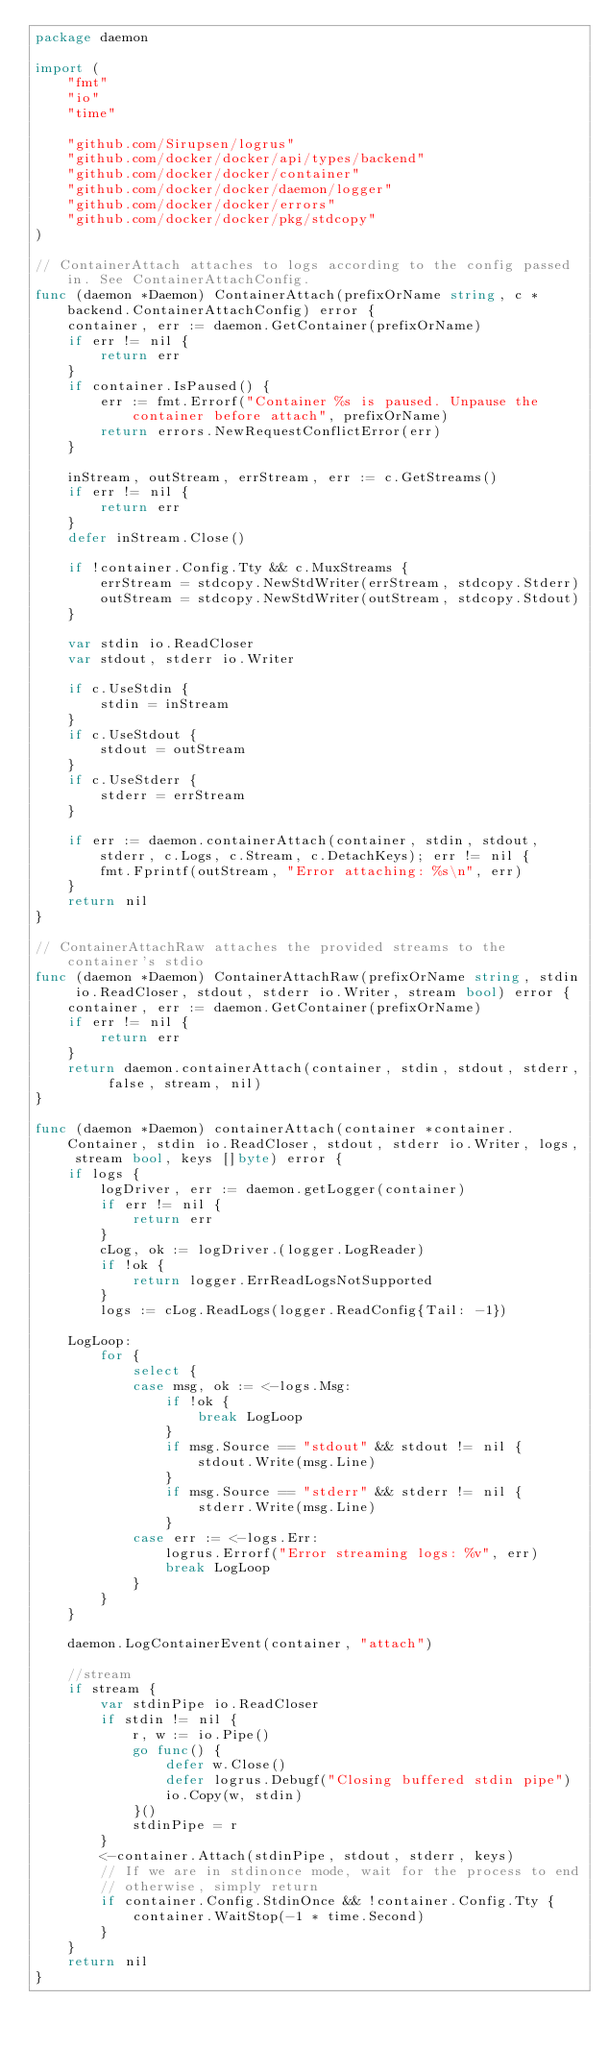<code> <loc_0><loc_0><loc_500><loc_500><_Go_>package daemon

import (
	"fmt"
	"io"
	"time"

	"github.com/Sirupsen/logrus"
	"github.com/docker/docker/api/types/backend"
	"github.com/docker/docker/container"
	"github.com/docker/docker/daemon/logger"
	"github.com/docker/docker/errors"
	"github.com/docker/docker/pkg/stdcopy"
)

// ContainerAttach attaches to logs according to the config passed in. See ContainerAttachConfig.
func (daemon *Daemon) ContainerAttach(prefixOrName string, c *backend.ContainerAttachConfig) error {
	container, err := daemon.GetContainer(prefixOrName)
	if err != nil {
		return err
	}
	if container.IsPaused() {
		err := fmt.Errorf("Container %s is paused. Unpause the container before attach", prefixOrName)
		return errors.NewRequestConflictError(err)
	}

	inStream, outStream, errStream, err := c.GetStreams()
	if err != nil {
		return err
	}
	defer inStream.Close()

	if !container.Config.Tty && c.MuxStreams {
		errStream = stdcopy.NewStdWriter(errStream, stdcopy.Stderr)
		outStream = stdcopy.NewStdWriter(outStream, stdcopy.Stdout)
	}

	var stdin io.ReadCloser
	var stdout, stderr io.Writer

	if c.UseStdin {
		stdin = inStream
	}
	if c.UseStdout {
		stdout = outStream
	}
	if c.UseStderr {
		stderr = errStream
	}

	if err := daemon.containerAttach(container, stdin, stdout, stderr, c.Logs, c.Stream, c.DetachKeys); err != nil {
		fmt.Fprintf(outStream, "Error attaching: %s\n", err)
	}
	return nil
}

// ContainerAttachRaw attaches the provided streams to the container's stdio
func (daemon *Daemon) ContainerAttachRaw(prefixOrName string, stdin io.ReadCloser, stdout, stderr io.Writer, stream bool) error {
	container, err := daemon.GetContainer(prefixOrName)
	if err != nil {
		return err
	}
	return daemon.containerAttach(container, stdin, stdout, stderr, false, stream, nil)
}

func (daemon *Daemon) containerAttach(container *container.Container, stdin io.ReadCloser, stdout, stderr io.Writer, logs, stream bool, keys []byte) error {
	if logs {
		logDriver, err := daemon.getLogger(container)
		if err != nil {
			return err
		}
		cLog, ok := logDriver.(logger.LogReader)
		if !ok {
			return logger.ErrReadLogsNotSupported
		}
		logs := cLog.ReadLogs(logger.ReadConfig{Tail: -1})

	LogLoop:
		for {
			select {
			case msg, ok := <-logs.Msg:
				if !ok {
					break LogLoop
				}
				if msg.Source == "stdout" && stdout != nil {
					stdout.Write(msg.Line)
				}
				if msg.Source == "stderr" && stderr != nil {
					stderr.Write(msg.Line)
				}
			case err := <-logs.Err:
				logrus.Errorf("Error streaming logs: %v", err)
				break LogLoop
			}
		}
	}

	daemon.LogContainerEvent(container, "attach")

	//stream
	if stream {
		var stdinPipe io.ReadCloser
		if stdin != nil {
			r, w := io.Pipe()
			go func() {
				defer w.Close()
				defer logrus.Debugf("Closing buffered stdin pipe")
				io.Copy(w, stdin)
			}()
			stdinPipe = r
		}
		<-container.Attach(stdinPipe, stdout, stderr, keys)
		// If we are in stdinonce mode, wait for the process to end
		// otherwise, simply return
		if container.Config.StdinOnce && !container.Config.Tty {
			container.WaitStop(-1 * time.Second)
		}
	}
	return nil
}
</code> 